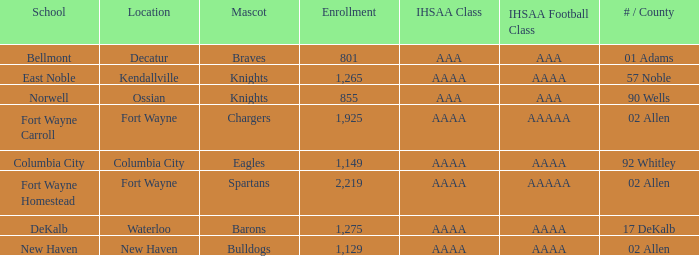I'm looking to parse the entire table for insights. Could you assist me with that? {'header': ['School', 'Location', 'Mascot', 'Enrollment', 'IHSAA Class', 'IHSAA Football Class', '# / County'], 'rows': [['Bellmont', 'Decatur', 'Braves', '801', 'AAA', 'AAA', '01 Adams'], ['East Noble', 'Kendallville', 'Knights', '1,265', 'AAAA', 'AAAA', '57 Noble'], ['Norwell', 'Ossian', 'Knights', '855', 'AAA', 'AAA', '90 Wells'], ['Fort Wayne Carroll', 'Fort Wayne', 'Chargers', '1,925', 'AAAA', 'AAAAA', '02 Allen'], ['Columbia City', 'Columbia City', 'Eagles', '1,149', 'AAAA', 'AAAA', '92 Whitley'], ['Fort Wayne Homestead', 'Fort Wayne', 'Spartans', '2,219', 'AAAA', 'AAAAA', '02 Allen'], ['DeKalb', 'Waterloo', 'Barons', '1,275', 'AAAA', 'AAAA', '17 DeKalb'], ['New Haven', 'New Haven', 'Bulldogs', '1,129', 'AAAA', 'AAAA', '02 Allen']]} What school has a mascot of the spartans with an AAAA IHSAA class and more than 1,275 enrolled? Fort Wayne Homestead. 